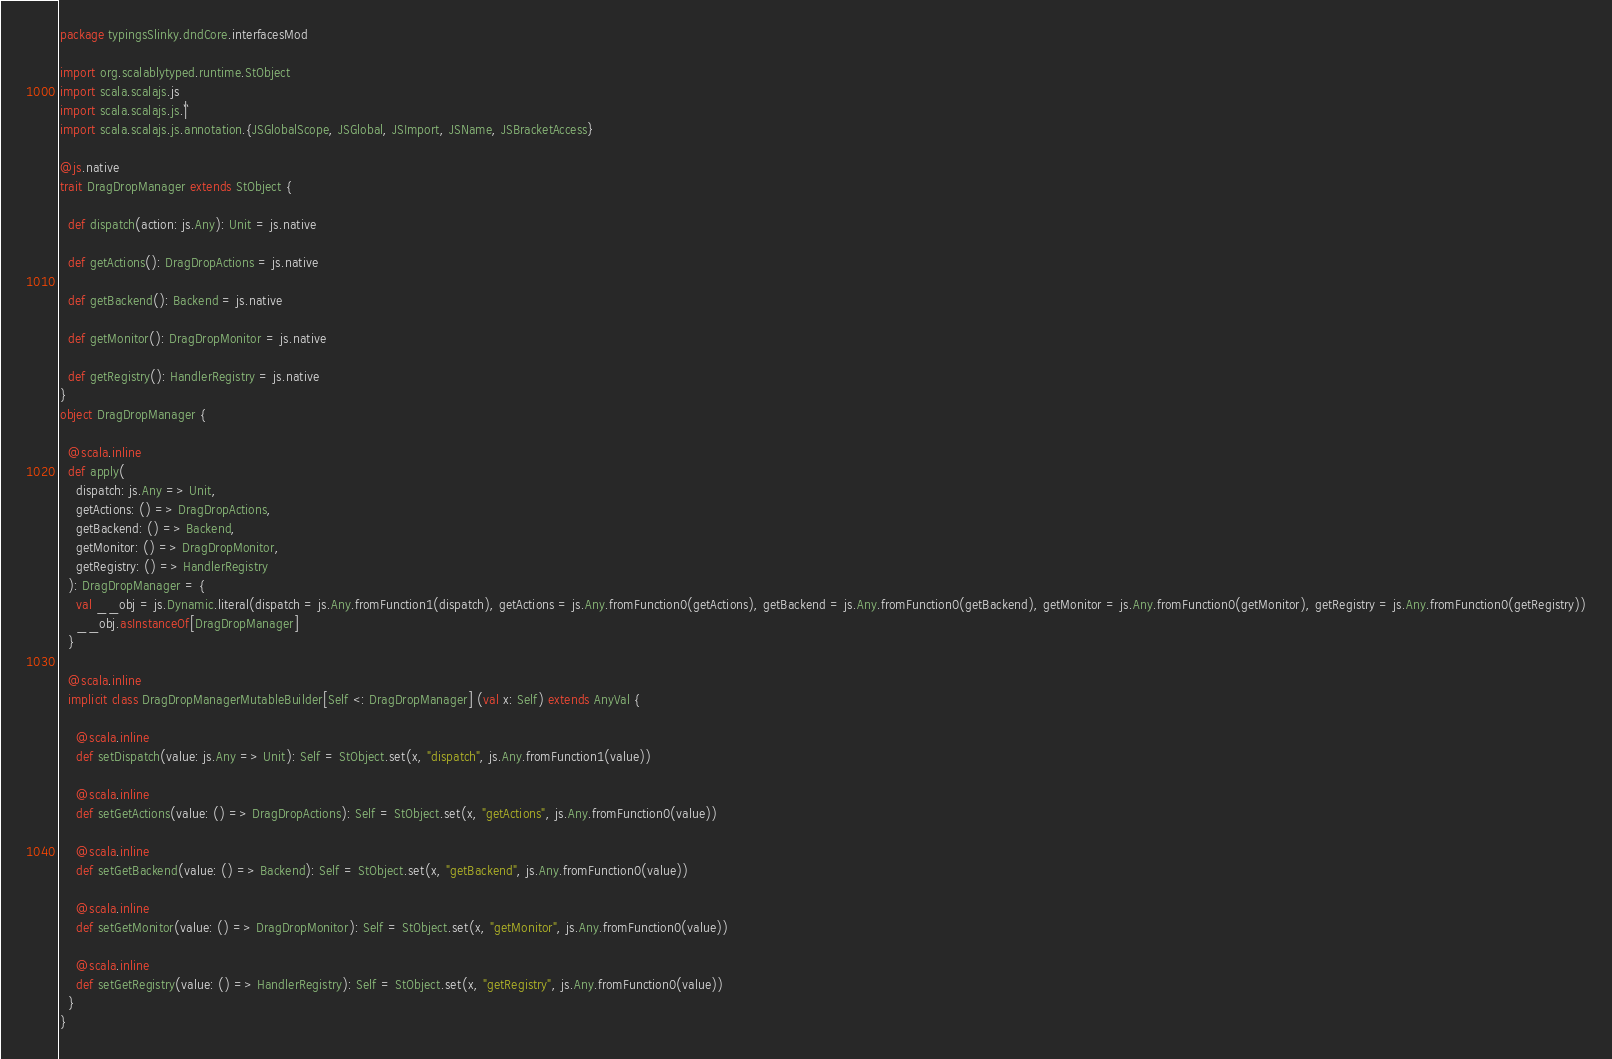<code> <loc_0><loc_0><loc_500><loc_500><_Scala_>package typingsSlinky.dndCore.interfacesMod

import org.scalablytyped.runtime.StObject
import scala.scalajs.js
import scala.scalajs.js.`|`
import scala.scalajs.js.annotation.{JSGlobalScope, JSGlobal, JSImport, JSName, JSBracketAccess}

@js.native
trait DragDropManager extends StObject {
  
  def dispatch(action: js.Any): Unit = js.native
  
  def getActions(): DragDropActions = js.native
  
  def getBackend(): Backend = js.native
  
  def getMonitor(): DragDropMonitor = js.native
  
  def getRegistry(): HandlerRegistry = js.native
}
object DragDropManager {
  
  @scala.inline
  def apply(
    dispatch: js.Any => Unit,
    getActions: () => DragDropActions,
    getBackend: () => Backend,
    getMonitor: () => DragDropMonitor,
    getRegistry: () => HandlerRegistry
  ): DragDropManager = {
    val __obj = js.Dynamic.literal(dispatch = js.Any.fromFunction1(dispatch), getActions = js.Any.fromFunction0(getActions), getBackend = js.Any.fromFunction0(getBackend), getMonitor = js.Any.fromFunction0(getMonitor), getRegistry = js.Any.fromFunction0(getRegistry))
    __obj.asInstanceOf[DragDropManager]
  }
  
  @scala.inline
  implicit class DragDropManagerMutableBuilder[Self <: DragDropManager] (val x: Self) extends AnyVal {
    
    @scala.inline
    def setDispatch(value: js.Any => Unit): Self = StObject.set(x, "dispatch", js.Any.fromFunction1(value))
    
    @scala.inline
    def setGetActions(value: () => DragDropActions): Self = StObject.set(x, "getActions", js.Any.fromFunction0(value))
    
    @scala.inline
    def setGetBackend(value: () => Backend): Self = StObject.set(x, "getBackend", js.Any.fromFunction0(value))
    
    @scala.inline
    def setGetMonitor(value: () => DragDropMonitor): Self = StObject.set(x, "getMonitor", js.Any.fromFunction0(value))
    
    @scala.inline
    def setGetRegistry(value: () => HandlerRegistry): Self = StObject.set(x, "getRegistry", js.Any.fromFunction0(value))
  }
}
</code> 